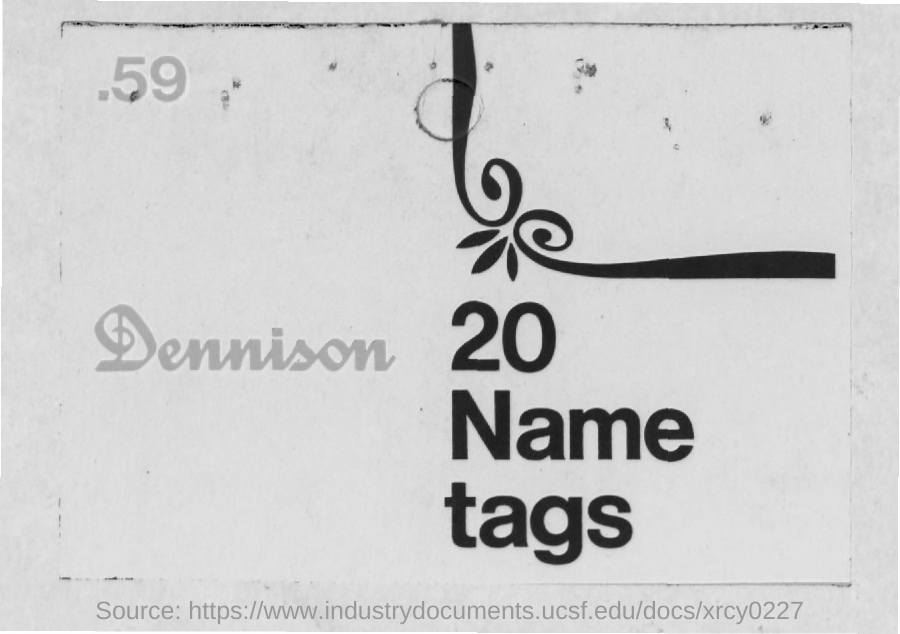Outline some significant characteristics in this image. The number of "Name tags" mentioned is 20. The number written in the left-top corner of the page is 59. 